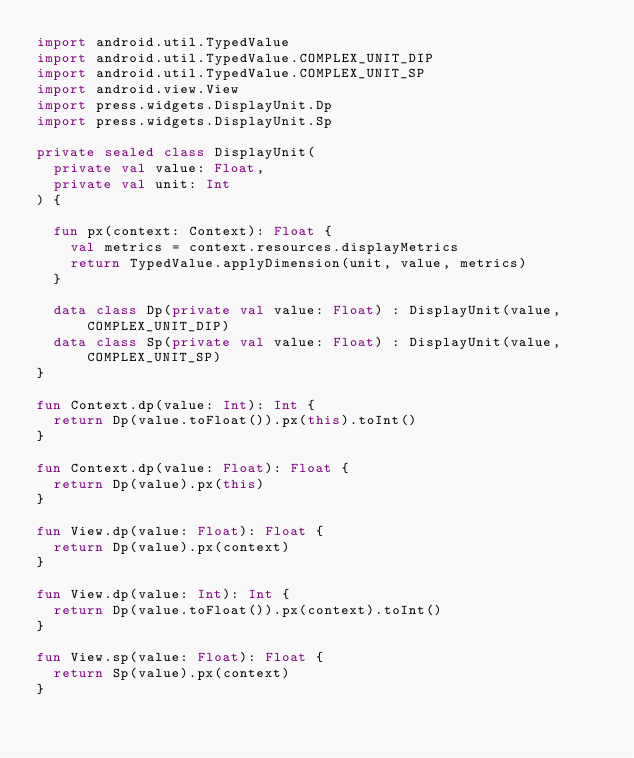Convert code to text. <code><loc_0><loc_0><loc_500><loc_500><_Kotlin_>import android.util.TypedValue
import android.util.TypedValue.COMPLEX_UNIT_DIP
import android.util.TypedValue.COMPLEX_UNIT_SP
import android.view.View
import press.widgets.DisplayUnit.Dp
import press.widgets.DisplayUnit.Sp

private sealed class DisplayUnit(
  private val value: Float,
  private val unit: Int
) {

  fun px(context: Context): Float {
    val metrics = context.resources.displayMetrics
    return TypedValue.applyDimension(unit, value, metrics)
  }

  data class Dp(private val value: Float) : DisplayUnit(value, COMPLEX_UNIT_DIP)
  data class Sp(private val value: Float) : DisplayUnit(value, COMPLEX_UNIT_SP)
}

fun Context.dp(value: Int): Int {
  return Dp(value.toFloat()).px(this).toInt()
}

fun Context.dp(value: Float): Float {
  return Dp(value).px(this)
}

fun View.dp(value: Float): Float {
  return Dp(value).px(context)
}

fun View.dp(value: Int): Int {
  return Dp(value.toFloat()).px(context).toInt()
}

fun View.sp(value: Float): Float {
  return Sp(value).px(context)
}
</code> 